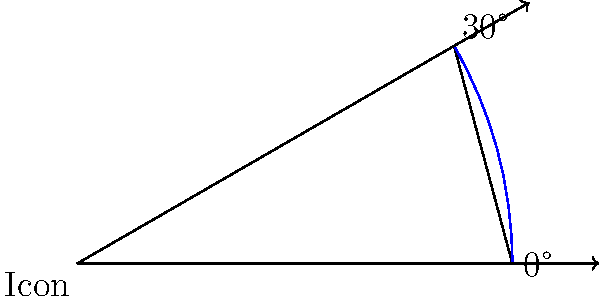In a Java Swing application using the Property design pattern, you're implementing a rotatable property icon. The icon starts at 0° and needs to be rotated 30° clockwise. How many radians does this rotation represent? To solve this problem, we need to follow these steps:

1. Recall the formula for converting degrees to radians:
   $$ \text{radians} = \frac{\text{degrees} \times \pi}{180°} $$

2. We're given the rotation angle in degrees: 30°

3. Substitute this value into the formula:
   $$ \text{radians} = \frac{30° \times \pi}{180°} $$

4. Simplify:
   $$ \text{radians} = \frac{\pi}{6} $$

5. This is our final answer. In a Java implementation, you might use `Math.PI / 6` to represent this value when setting the rotation property of the icon.
Answer: $\frac{\pi}{6}$ radians 